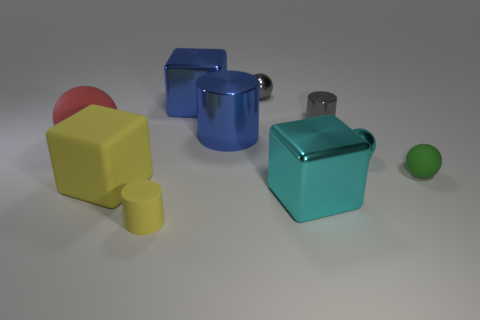What number of small gray rubber things are there?
Your answer should be very brief. 0. Is the material of the cylinder that is in front of the blue metal cylinder the same as the small gray cylinder?
Your answer should be very brief. No. What is the big cube that is both right of the small rubber cylinder and in front of the large sphere made of?
Keep it short and to the point. Metal. There is a cube that is the same color as the small rubber cylinder; what is its size?
Provide a short and direct response. Large. There is a big object on the right side of the gray thing behind the gray shiny cylinder; what is its material?
Your answer should be very brief. Metal. What is the size of the blue shiny object that is in front of the tiny cylinder that is behind the cylinder that is in front of the large matte ball?
Provide a short and direct response. Large. What number of big red objects are the same material as the yellow cylinder?
Keep it short and to the point. 1. There is a small sphere behind the big shiny cube behind the large metal cylinder; what is its color?
Offer a terse response. Gray. What number of things are small spheres or cyan metallic blocks that are left of the gray cylinder?
Keep it short and to the point. 4. Are there any metal blocks of the same color as the big cylinder?
Keep it short and to the point. Yes. 